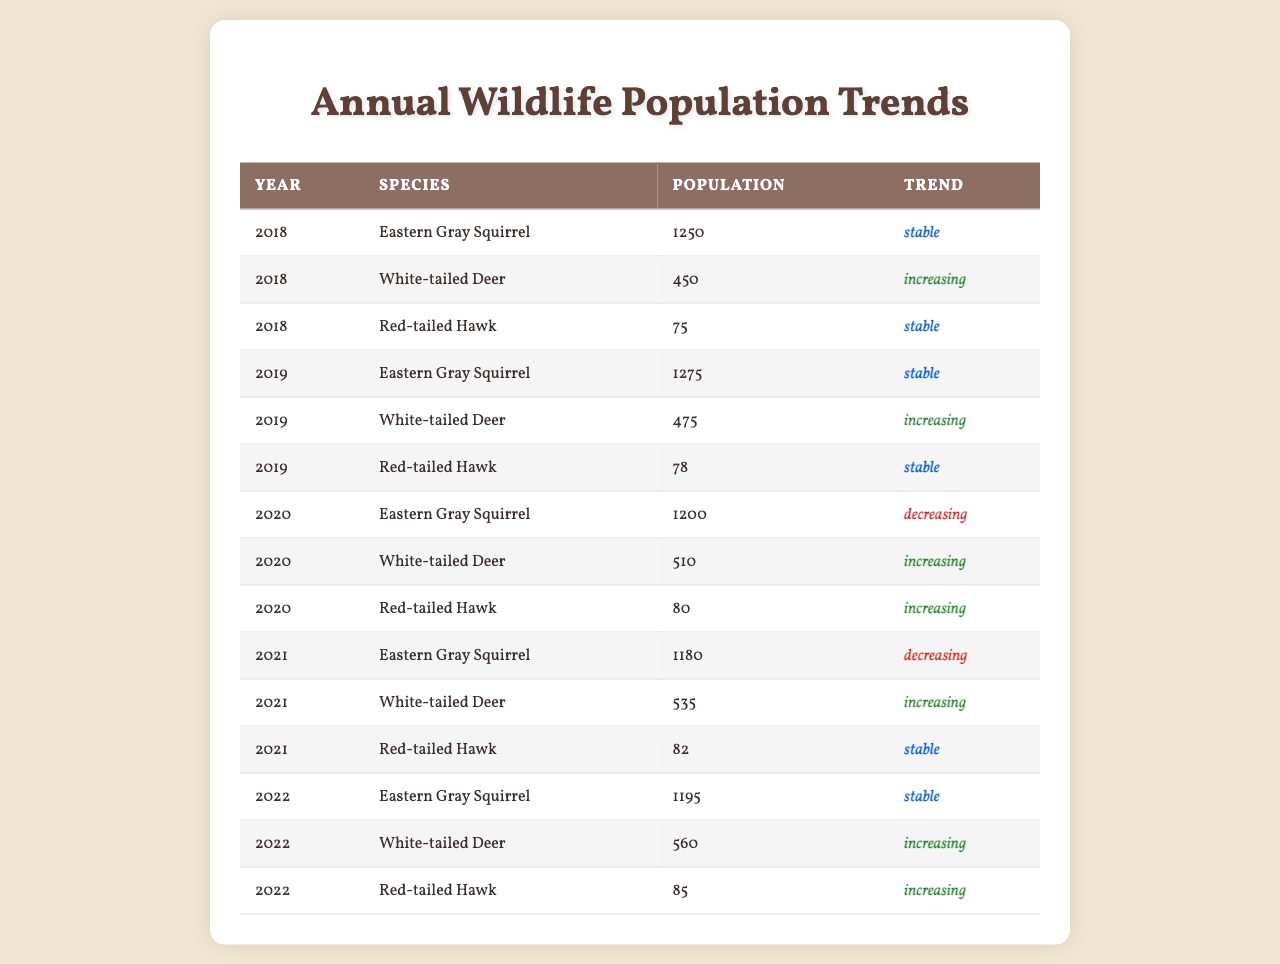What was the population of the White-tailed Deer in 2020? The table shows that in 2020, the population of the White-tailed Deer was listed as 510.
Answer: 510 Which species had a stable trend in 2021? Referring to the table, the Red-tailed Hawk had a stable trend in 2021.
Answer: Red-tailed Hawk What was the total population of Eastern Gray Squirrels over the years 2018 to 2021? The populations of Eastern Gray Squirrels for the years 2018 to 2021 are 1250, 1275, 1200, and 1180 respectively. Summing these values gives 1250 + 1275 + 1200 + 1180 = 4905.
Answer: 4905 Did the population of Red-tailed Hawks increase from 2020 to 2022? The table shows that the population of Red-tailed Hawks was 80 in 2020 and increased to 85 in 2022. Hence, the population did increase.
Answer: Yes What is the average population of White-tailed Deer from 2018 to 2022? The populations for White-tailed Deer from 2018 to 2022 are 450, 475, 510, 535, and 560 respectively. Summing these gives 450 + 475 + 510 + 535 + 560 = 2530. Dividing by 5 to find the average gives 2530 / 5 = 506.
Answer: 506 In which year did the Eastern Gray Squirrel have its highest population? The populations of Eastern Gray Squirrels over the years are listed as 1250, 1275, 1200, 1180, and 1195. The highest population was 1275 in 2019.
Answer: 2019 Which species had the highest population in 2022? Referring to the table, the White-tailed Deer had the highest population in 2022 at 560.
Answer: White-tailed Deer Was there a year when the population of Red-tailed Hawks was stable while the population of Eastern Gray Squirrels was decreasing? In 2020, the trend for Eastern Gray Squirrels was decreasing, while the trend for Red-tailed Hawks was increasing. Therefore, there was no such year.
Answer: No If we consider only years where the population of Eastern Gray Squirrels decreased, what was the population trend of Red-tailed Hawks for those years? The Eastern Gray Squirrel population decreased in 2020 and 2021, during which the Red-tailed Hawk population had an increasing trend in 2020 and a stable trend in 2021.
Answer: Increasing and Stable In what year did the White-tailed Deer first surpass a population of 500? The population of White-tailed Deer surpassed 500 for the first time in 2020 when it reached 510.
Answer: 2020 